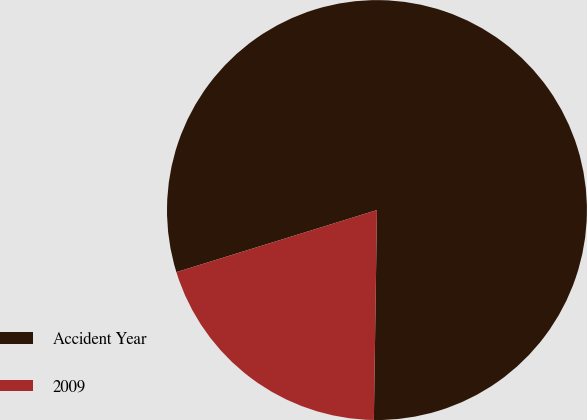Convert chart. <chart><loc_0><loc_0><loc_500><loc_500><pie_chart><fcel>Accident Year<fcel>2009<nl><fcel>80.01%<fcel>19.99%<nl></chart> 